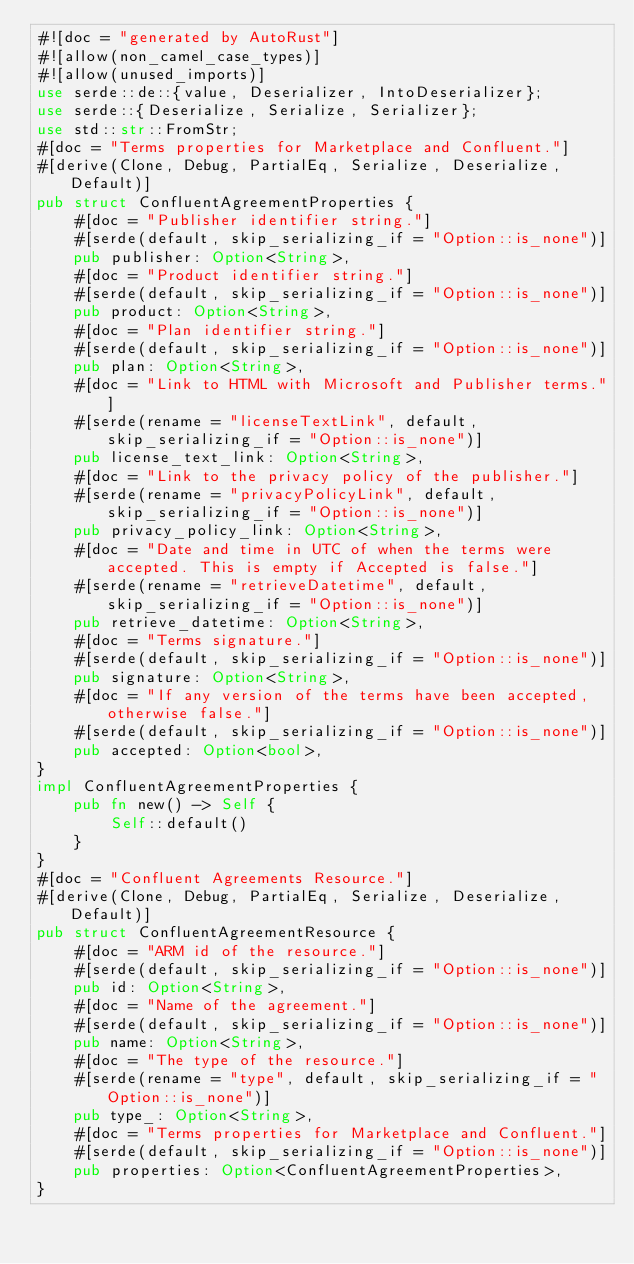<code> <loc_0><loc_0><loc_500><loc_500><_Rust_>#![doc = "generated by AutoRust"]
#![allow(non_camel_case_types)]
#![allow(unused_imports)]
use serde::de::{value, Deserializer, IntoDeserializer};
use serde::{Deserialize, Serialize, Serializer};
use std::str::FromStr;
#[doc = "Terms properties for Marketplace and Confluent."]
#[derive(Clone, Debug, PartialEq, Serialize, Deserialize, Default)]
pub struct ConfluentAgreementProperties {
    #[doc = "Publisher identifier string."]
    #[serde(default, skip_serializing_if = "Option::is_none")]
    pub publisher: Option<String>,
    #[doc = "Product identifier string."]
    #[serde(default, skip_serializing_if = "Option::is_none")]
    pub product: Option<String>,
    #[doc = "Plan identifier string."]
    #[serde(default, skip_serializing_if = "Option::is_none")]
    pub plan: Option<String>,
    #[doc = "Link to HTML with Microsoft and Publisher terms."]
    #[serde(rename = "licenseTextLink", default, skip_serializing_if = "Option::is_none")]
    pub license_text_link: Option<String>,
    #[doc = "Link to the privacy policy of the publisher."]
    #[serde(rename = "privacyPolicyLink", default, skip_serializing_if = "Option::is_none")]
    pub privacy_policy_link: Option<String>,
    #[doc = "Date and time in UTC of when the terms were accepted. This is empty if Accepted is false."]
    #[serde(rename = "retrieveDatetime", default, skip_serializing_if = "Option::is_none")]
    pub retrieve_datetime: Option<String>,
    #[doc = "Terms signature."]
    #[serde(default, skip_serializing_if = "Option::is_none")]
    pub signature: Option<String>,
    #[doc = "If any version of the terms have been accepted, otherwise false."]
    #[serde(default, skip_serializing_if = "Option::is_none")]
    pub accepted: Option<bool>,
}
impl ConfluentAgreementProperties {
    pub fn new() -> Self {
        Self::default()
    }
}
#[doc = "Confluent Agreements Resource."]
#[derive(Clone, Debug, PartialEq, Serialize, Deserialize, Default)]
pub struct ConfluentAgreementResource {
    #[doc = "ARM id of the resource."]
    #[serde(default, skip_serializing_if = "Option::is_none")]
    pub id: Option<String>,
    #[doc = "Name of the agreement."]
    #[serde(default, skip_serializing_if = "Option::is_none")]
    pub name: Option<String>,
    #[doc = "The type of the resource."]
    #[serde(rename = "type", default, skip_serializing_if = "Option::is_none")]
    pub type_: Option<String>,
    #[doc = "Terms properties for Marketplace and Confluent."]
    #[serde(default, skip_serializing_if = "Option::is_none")]
    pub properties: Option<ConfluentAgreementProperties>,
}</code> 